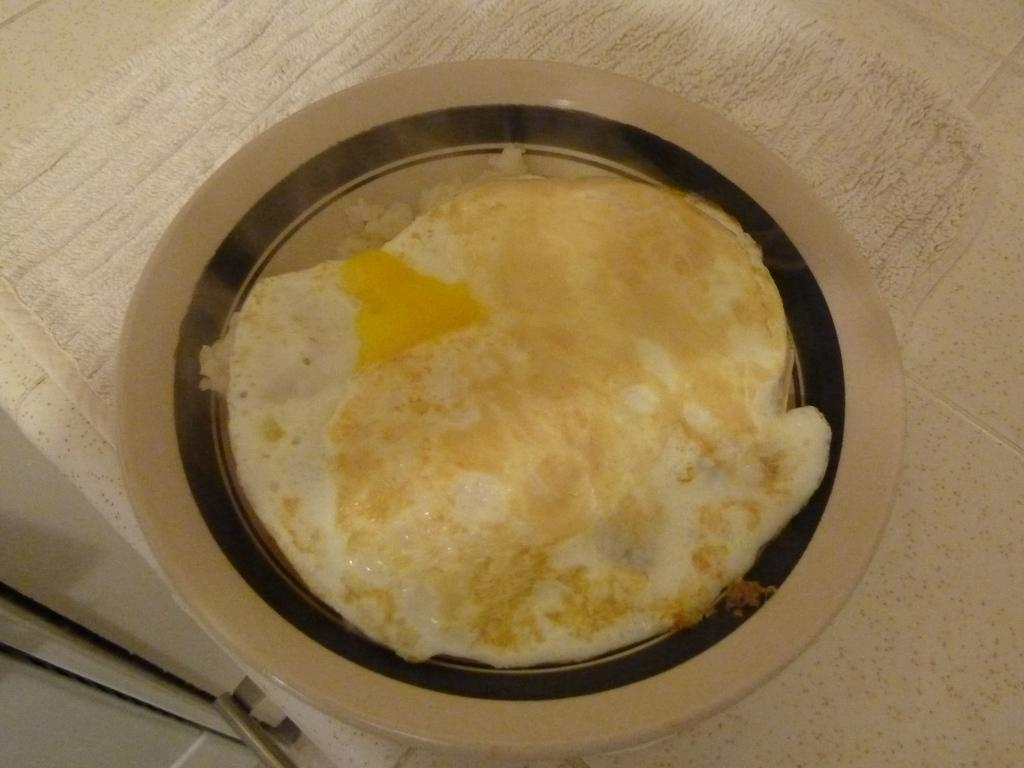What is on the plate that is visible in the image? There is a plate with food in the image. What else can be seen on the surface in the image? There is a cloth on the surface in the image. Where is the toothbrush located in the image? There is no toothbrush present in the image. Who is the creator of the food on the plate in the image? The creator of the food is not visible or identifiable in the image. 